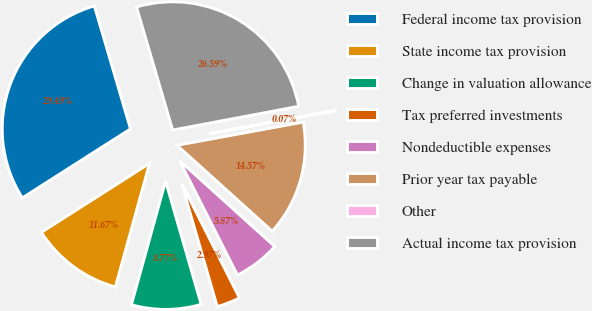Convert chart to OTSL. <chart><loc_0><loc_0><loc_500><loc_500><pie_chart><fcel>Federal income tax provision<fcel>State income tax provision<fcel>Change in valuation allowance<fcel>Tax preferred investments<fcel>Nondeductible expenses<fcel>Prior year tax payable<fcel>Other<fcel>Actual income tax provision<nl><fcel>29.48%<fcel>11.67%<fcel>8.77%<fcel>2.97%<fcel>5.87%<fcel>14.57%<fcel>0.07%<fcel>26.58%<nl></chart> 